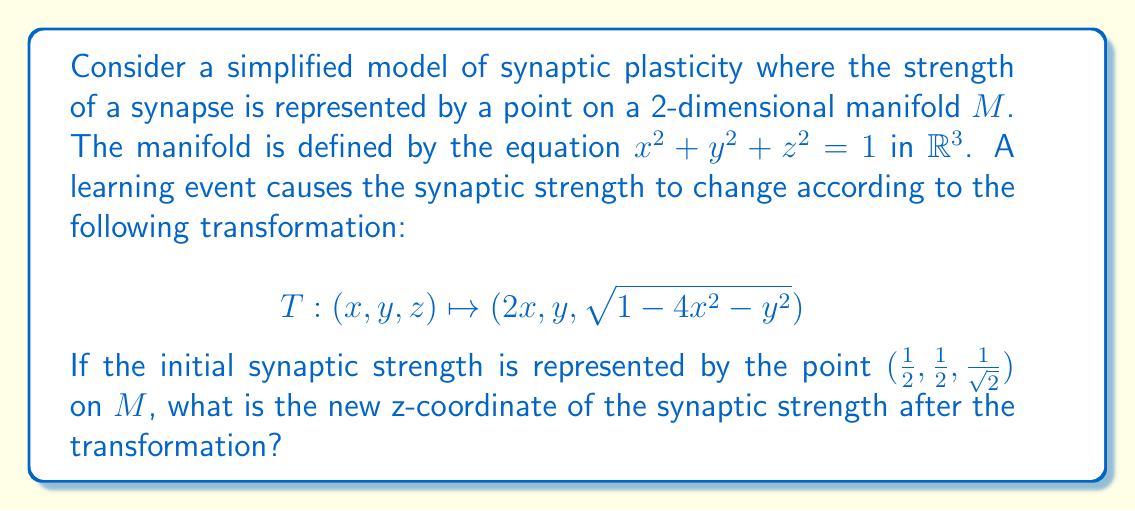Help me with this question. Let's approach this step-by-step:

1) First, we need to verify that the initial point $(1/2, 1/2, 1/\sqrt{2})$ is indeed on the manifold $M$. We can do this by substituting these coordinates into the equation of $M$:

   $$(1/2)^2 + (1/2)^2 + (1/\sqrt{2})^2 = 1/4 + 1/4 + 1/2 = 1$$

   This confirms that the initial point is on $M$.

2) Now, we apply the transformation $T$ to this point:

   $T(1/2, 1/2, 1/\sqrt{2}) = (2(1/2), 1/2, \sqrt{1-4(1/2)^2-(1/2)^2})$

3) Simplify the x and y coordinates:

   $(1, 1/2, \sqrt{1-4(1/4)-(1/4)})$

4) Simplify under the square root:

   $(1, 1/2, \sqrt{1-1-1/4}) = (1, 1/2, \sqrt{-1/4})$

5) The expression under the square root is negative, which means the transformation has moved the point off the manifold $M$. In the context of synaptic plasticity, this could represent a biologically impossible state.

6) However, if we consider only the real part of this transformation (which might be a reasonable approach in a biological context), we would take the absolute value inside the square root:

   $(1, 1/2, \sqrt{1/4}) = (1, 1/2, 1/2)$
Answer: $1/2$ 